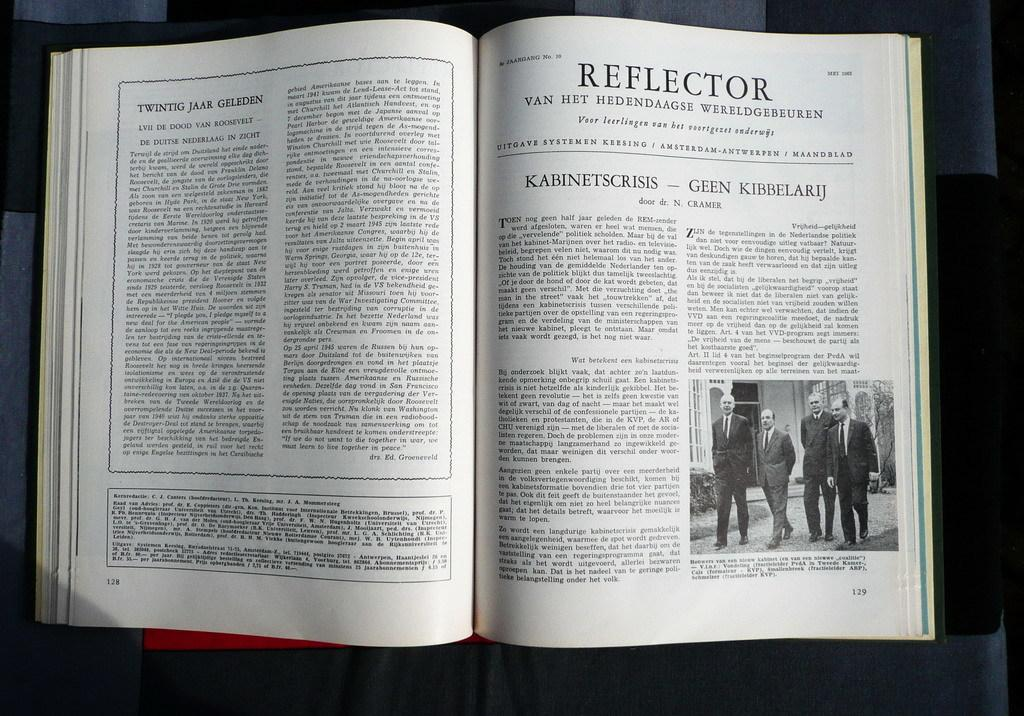<image>
Summarize the visual content of the image. A book is open to a section labeled Reflector. 